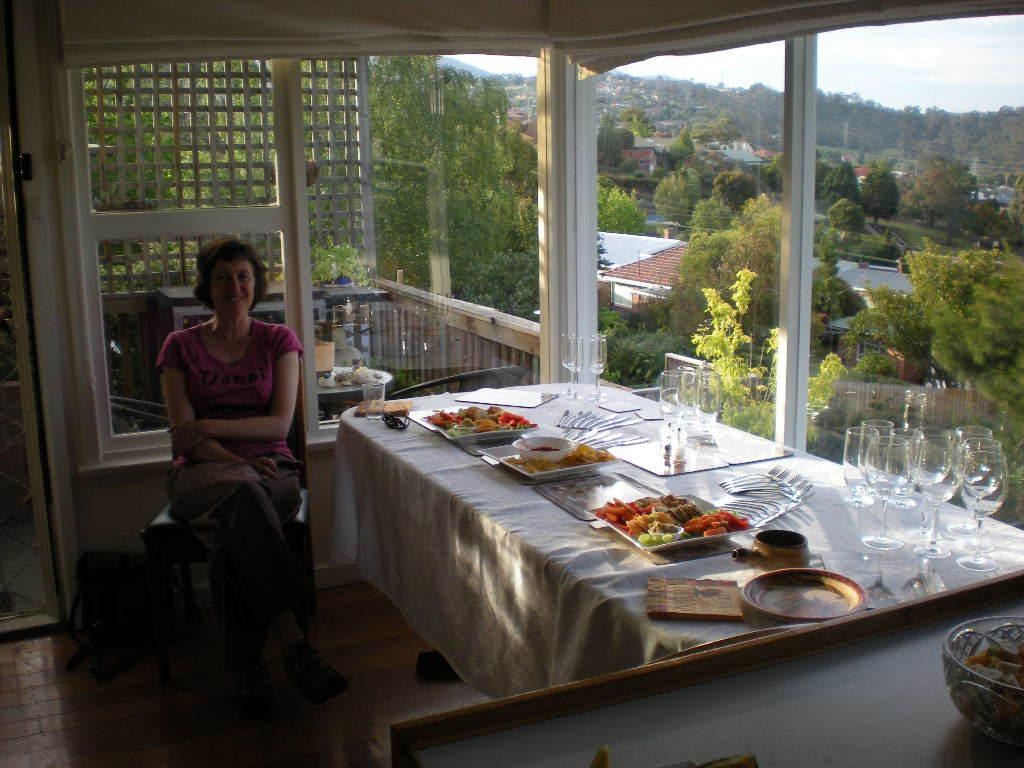What is located on the right side of the image? There is a table on the right side of the image. What can be found on the table? Plates, food items, and glasses are on the table. Who is present in the image? There is a woman sitting on the left side of the image. What can be seen outside the building? Trees and other buildings are visible outside the building. Can you see a rabbit playing with a yam near the gate in the image? There is no rabbit, yam, or gate present in the image. 